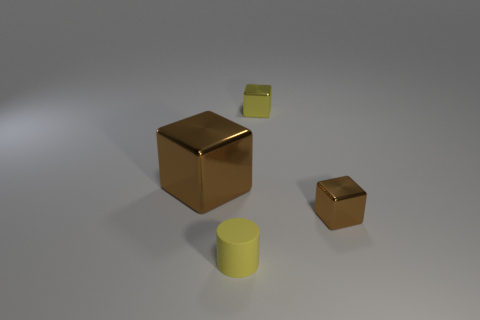Subtract all brown blocks. How many were subtracted if there are1brown blocks left? 1 Add 2 blue rubber cubes. How many objects exist? 6 Subtract all brown metal cubes. How many cubes are left? 1 Subtract all yellow cubes. How many cubes are left? 2 Subtract 0 green blocks. How many objects are left? 4 Subtract all cylinders. How many objects are left? 3 Subtract 1 cylinders. How many cylinders are left? 0 Subtract all green cylinders. Subtract all purple spheres. How many cylinders are left? 1 Subtract all cyan cubes. How many brown cylinders are left? 0 Subtract all tiny yellow cubes. Subtract all large purple shiny things. How many objects are left? 3 